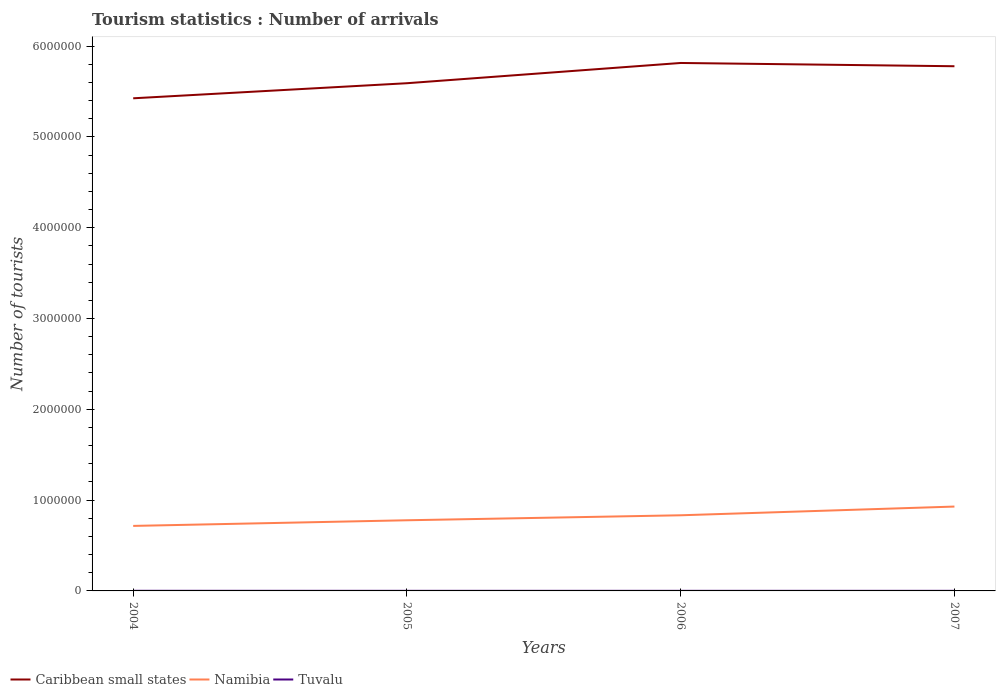Is the number of lines equal to the number of legend labels?
Give a very brief answer. Yes. Across all years, what is the maximum number of tourist arrivals in Namibia?
Your answer should be very brief. 7.16e+05. In which year was the number of tourist arrivals in Namibia maximum?
Give a very brief answer. 2004. What is the total number of tourist arrivals in Caribbean small states in the graph?
Provide a succinct answer. -3.89e+05. What is the difference between the highest and the second highest number of tourist arrivals in Namibia?
Ensure brevity in your answer.  2.13e+05. What is the difference between the highest and the lowest number of tourist arrivals in Namibia?
Ensure brevity in your answer.  2. Is the number of tourist arrivals in Caribbean small states strictly greater than the number of tourist arrivals in Namibia over the years?
Keep it short and to the point. No. How many lines are there?
Keep it short and to the point. 3. What is the difference between two consecutive major ticks on the Y-axis?
Provide a short and direct response. 1.00e+06. Does the graph contain any zero values?
Provide a short and direct response. No. Where does the legend appear in the graph?
Provide a short and direct response. Bottom left. What is the title of the graph?
Provide a succinct answer. Tourism statistics : Number of arrivals. Does "Nicaragua" appear as one of the legend labels in the graph?
Provide a succinct answer. No. What is the label or title of the Y-axis?
Your answer should be compact. Number of tourists. What is the Number of tourists in Caribbean small states in 2004?
Keep it short and to the point. 5.42e+06. What is the Number of tourists of Namibia in 2004?
Provide a succinct answer. 7.16e+05. What is the Number of tourists of Tuvalu in 2004?
Your response must be concise. 1300. What is the Number of tourists in Caribbean small states in 2005?
Your answer should be very brief. 5.59e+06. What is the Number of tourists of Namibia in 2005?
Your answer should be very brief. 7.78e+05. What is the Number of tourists of Tuvalu in 2005?
Offer a terse response. 1100. What is the Number of tourists of Caribbean small states in 2006?
Your answer should be compact. 5.81e+06. What is the Number of tourists of Namibia in 2006?
Provide a succinct answer. 8.33e+05. What is the Number of tourists of Tuvalu in 2006?
Provide a short and direct response. 1100. What is the Number of tourists in Caribbean small states in 2007?
Offer a very short reply. 5.78e+06. What is the Number of tourists of Namibia in 2007?
Keep it short and to the point. 9.29e+05. What is the Number of tourists in Tuvalu in 2007?
Provide a short and direct response. 1100. Across all years, what is the maximum Number of tourists of Caribbean small states?
Give a very brief answer. 5.81e+06. Across all years, what is the maximum Number of tourists in Namibia?
Ensure brevity in your answer.  9.29e+05. Across all years, what is the maximum Number of tourists in Tuvalu?
Offer a terse response. 1300. Across all years, what is the minimum Number of tourists of Caribbean small states?
Offer a terse response. 5.42e+06. Across all years, what is the minimum Number of tourists in Namibia?
Keep it short and to the point. 7.16e+05. Across all years, what is the minimum Number of tourists of Tuvalu?
Make the answer very short. 1100. What is the total Number of tourists in Caribbean small states in the graph?
Keep it short and to the point. 2.26e+07. What is the total Number of tourists of Namibia in the graph?
Provide a short and direct response. 3.26e+06. What is the total Number of tourists of Tuvalu in the graph?
Give a very brief answer. 4600. What is the difference between the Number of tourists in Caribbean small states in 2004 and that in 2005?
Make the answer very short. -1.66e+05. What is the difference between the Number of tourists in Namibia in 2004 and that in 2005?
Keep it short and to the point. -6.20e+04. What is the difference between the Number of tourists of Caribbean small states in 2004 and that in 2006?
Ensure brevity in your answer.  -3.89e+05. What is the difference between the Number of tourists in Namibia in 2004 and that in 2006?
Your answer should be compact. -1.17e+05. What is the difference between the Number of tourists in Tuvalu in 2004 and that in 2006?
Give a very brief answer. 200. What is the difference between the Number of tourists of Caribbean small states in 2004 and that in 2007?
Make the answer very short. -3.53e+05. What is the difference between the Number of tourists in Namibia in 2004 and that in 2007?
Give a very brief answer. -2.13e+05. What is the difference between the Number of tourists in Tuvalu in 2004 and that in 2007?
Ensure brevity in your answer.  200. What is the difference between the Number of tourists of Caribbean small states in 2005 and that in 2006?
Your answer should be very brief. -2.23e+05. What is the difference between the Number of tourists of Namibia in 2005 and that in 2006?
Provide a succinct answer. -5.50e+04. What is the difference between the Number of tourists of Tuvalu in 2005 and that in 2006?
Ensure brevity in your answer.  0. What is the difference between the Number of tourists in Caribbean small states in 2005 and that in 2007?
Your answer should be very brief. -1.87e+05. What is the difference between the Number of tourists in Namibia in 2005 and that in 2007?
Your answer should be very brief. -1.51e+05. What is the difference between the Number of tourists in Caribbean small states in 2006 and that in 2007?
Your response must be concise. 3.60e+04. What is the difference between the Number of tourists in Namibia in 2006 and that in 2007?
Ensure brevity in your answer.  -9.60e+04. What is the difference between the Number of tourists of Caribbean small states in 2004 and the Number of tourists of Namibia in 2005?
Keep it short and to the point. 4.65e+06. What is the difference between the Number of tourists in Caribbean small states in 2004 and the Number of tourists in Tuvalu in 2005?
Your answer should be very brief. 5.42e+06. What is the difference between the Number of tourists in Namibia in 2004 and the Number of tourists in Tuvalu in 2005?
Your answer should be very brief. 7.15e+05. What is the difference between the Number of tourists of Caribbean small states in 2004 and the Number of tourists of Namibia in 2006?
Provide a short and direct response. 4.59e+06. What is the difference between the Number of tourists in Caribbean small states in 2004 and the Number of tourists in Tuvalu in 2006?
Your response must be concise. 5.42e+06. What is the difference between the Number of tourists in Namibia in 2004 and the Number of tourists in Tuvalu in 2006?
Your response must be concise. 7.15e+05. What is the difference between the Number of tourists of Caribbean small states in 2004 and the Number of tourists of Namibia in 2007?
Provide a short and direct response. 4.50e+06. What is the difference between the Number of tourists in Caribbean small states in 2004 and the Number of tourists in Tuvalu in 2007?
Offer a terse response. 5.42e+06. What is the difference between the Number of tourists of Namibia in 2004 and the Number of tourists of Tuvalu in 2007?
Provide a short and direct response. 7.15e+05. What is the difference between the Number of tourists of Caribbean small states in 2005 and the Number of tourists of Namibia in 2006?
Make the answer very short. 4.76e+06. What is the difference between the Number of tourists in Caribbean small states in 2005 and the Number of tourists in Tuvalu in 2006?
Offer a very short reply. 5.59e+06. What is the difference between the Number of tourists of Namibia in 2005 and the Number of tourists of Tuvalu in 2006?
Give a very brief answer. 7.77e+05. What is the difference between the Number of tourists of Caribbean small states in 2005 and the Number of tourists of Namibia in 2007?
Ensure brevity in your answer.  4.66e+06. What is the difference between the Number of tourists in Caribbean small states in 2005 and the Number of tourists in Tuvalu in 2007?
Your response must be concise. 5.59e+06. What is the difference between the Number of tourists of Namibia in 2005 and the Number of tourists of Tuvalu in 2007?
Make the answer very short. 7.77e+05. What is the difference between the Number of tourists of Caribbean small states in 2006 and the Number of tourists of Namibia in 2007?
Provide a succinct answer. 4.88e+06. What is the difference between the Number of tourists of Caribbean small states in 2006 and the Number of tourists of Tuvalu in 2007?
Your answer should be compact. 5.81e+06. What is the difference between the Number of tourists in Namibia in 2006 and the Number of tourists in Tuvalu in 2007?
Make the answer very short. 8.32e+05. What is the average Number of tourists in Caribbean small states per year?
Provide a succinct answer. 5.65e+06. What is the average Number of tourists in Namibia per year?
Your answer should be very brief. 8.14e+05. What is the average Number of tourists of Tuvalu per year?
Your answer should be very brief. 1150. In the year 2004, what is the difference between the Number of tourists in Caribbean small states and Number of tourists in Namibia?
Give a very brief answer. 4.71e+06. In the year 2004, what is the difference between the Number of tourists of Caribbean small states and Number of tourists of Tuvalu?
Give a very brief answer. 5.42e+06. In the year 2004, what is the difference between the Number of tourists of Namibia and Number of tourists of Tuvalu?
Keep it short and to the point. 7.15e+05. In the year 2005, what is the difference between the Number of tourists of Caribbean small states and Number of tourists of Namibia?
Give a very brief answer. 4.81e+06. In the year 2005, what is the difference between the Number of tourists of Caribbean small states and Number of tourists of Tuvalu?
Offer a very short reply. 5.59e+06. In the year 2005, what is the difference between the Number of tourists of Namibia and Number of tourists of Tuvalu?
Keep it short and to the point. 7.77e+05. In the year 2006, what is the difference between the Number of tourists of Caribbean small states and Number of tourists of Namibia?
Your answer should be very brief. 4.98e+06. In the year 2006, what is the difference between the Number of tourists in Caribbean small states and Number of tourists in Tuvalu?
Make the answer very short. 5.81e+06. In the year 2006, what is the difference between the Number of tourists in Namibia and Number of tourists in Tuvalu?
Provide a succinct answer. 8.32e+05. In the year 2007, what is the difference between the Number of tourists in Caribbean small states and Number of tourists in Namibia?
Your response must be concise. 4.85e+06. In the year 2007, what is the difference between the Number of tourists of Caribbean small states and Number of tourists of Tuvalu?
Your response must be concise. 5.78e+06. In the year 2007, what is the difference between the Number of tourists in Namibia and Number of tourists in Tuvalu?
Provide a succinct answer. 9.28e+05. What is the ratio of the Number of tourists in Caribbean small states in 2004 to that in 2005?
Offer a very short reply. 0.97. What is the ratio of the Number of tourists of Namibia in 2004 to that in 2005?
Your answer should be compact. 0.92. What is the ratio of the Number of tourists of Tuvalu in 2004 to that in 2005?
Give a very brief answer. 1.18. What is the ratio of the Number of tourists in Caribbean small states in 2004 to that in 2006?
Your answer should be compact. 0.93. What is the ratio of the Number of tourists in Namibia in 2004 to that in 2006?
Provide a short and direct response. 0.86. What is the ratio of the Number of tourists in Tuvalu in 2004 to that in 2006?
Your response must be concise. 1.18. What is the ratio of the Number of tourists of Caribbean small states in 2004 to that in 2007?
Give a very brief answer. 0.94. What is the ratio of the Number of tourists of Namibia in 2004 to that in 2007?
Offer a terse response. 0.77. What is the ratio of the Number of tourists of Tuvalu in 2004 to that in 2007?
Your response must be concise. 1.18. What is the ratio of the Number of tourists of Caribbean small states in 2005 to that in 2006?
Keep it short and to the point. 0.96. What is the ratio of the Number of tourists in Namibia in 2005 to that in 2006?
Your answer should be very brief. 0.93. What is the ratio of the Number of tourists in Caribbean small states in 2005 to that in 2007?
Provide a short and direct response. 0.97. What is the ratio of the Number of tourists in Namibia in 2005 to that in 2007?
Ensure brevity in your answer.  0.84. What is the ratio of the Number of tourists in Namibia in 2006 to that in 2007?
Ensure brevity in your answer.  0.9. What is the difference between the highest and the second highest Number of tourists of Caribbean small states?
Give a very brief answer. 3.60e+04. What is the difference between the highest and the second highest Number of tourists of Namibia?
Provide a short and direct response. 9.60e+04. What is the difference between the highest and the second highest Number of tourists in Tuvalu?
Provide a succinct answer. 200. What is the difference between the highest and the lowest Number of tourists in Caribbean small states?
Offer a terse response. 3.89e+05. What is the difference between the highest and the lowest Number of tourists of Namibia?
Your answer should be very brief. 2.13e+05. What is the difference between the highest and the lowest Number of tourists of Tuvalu?
Offer a terse response. 200. 